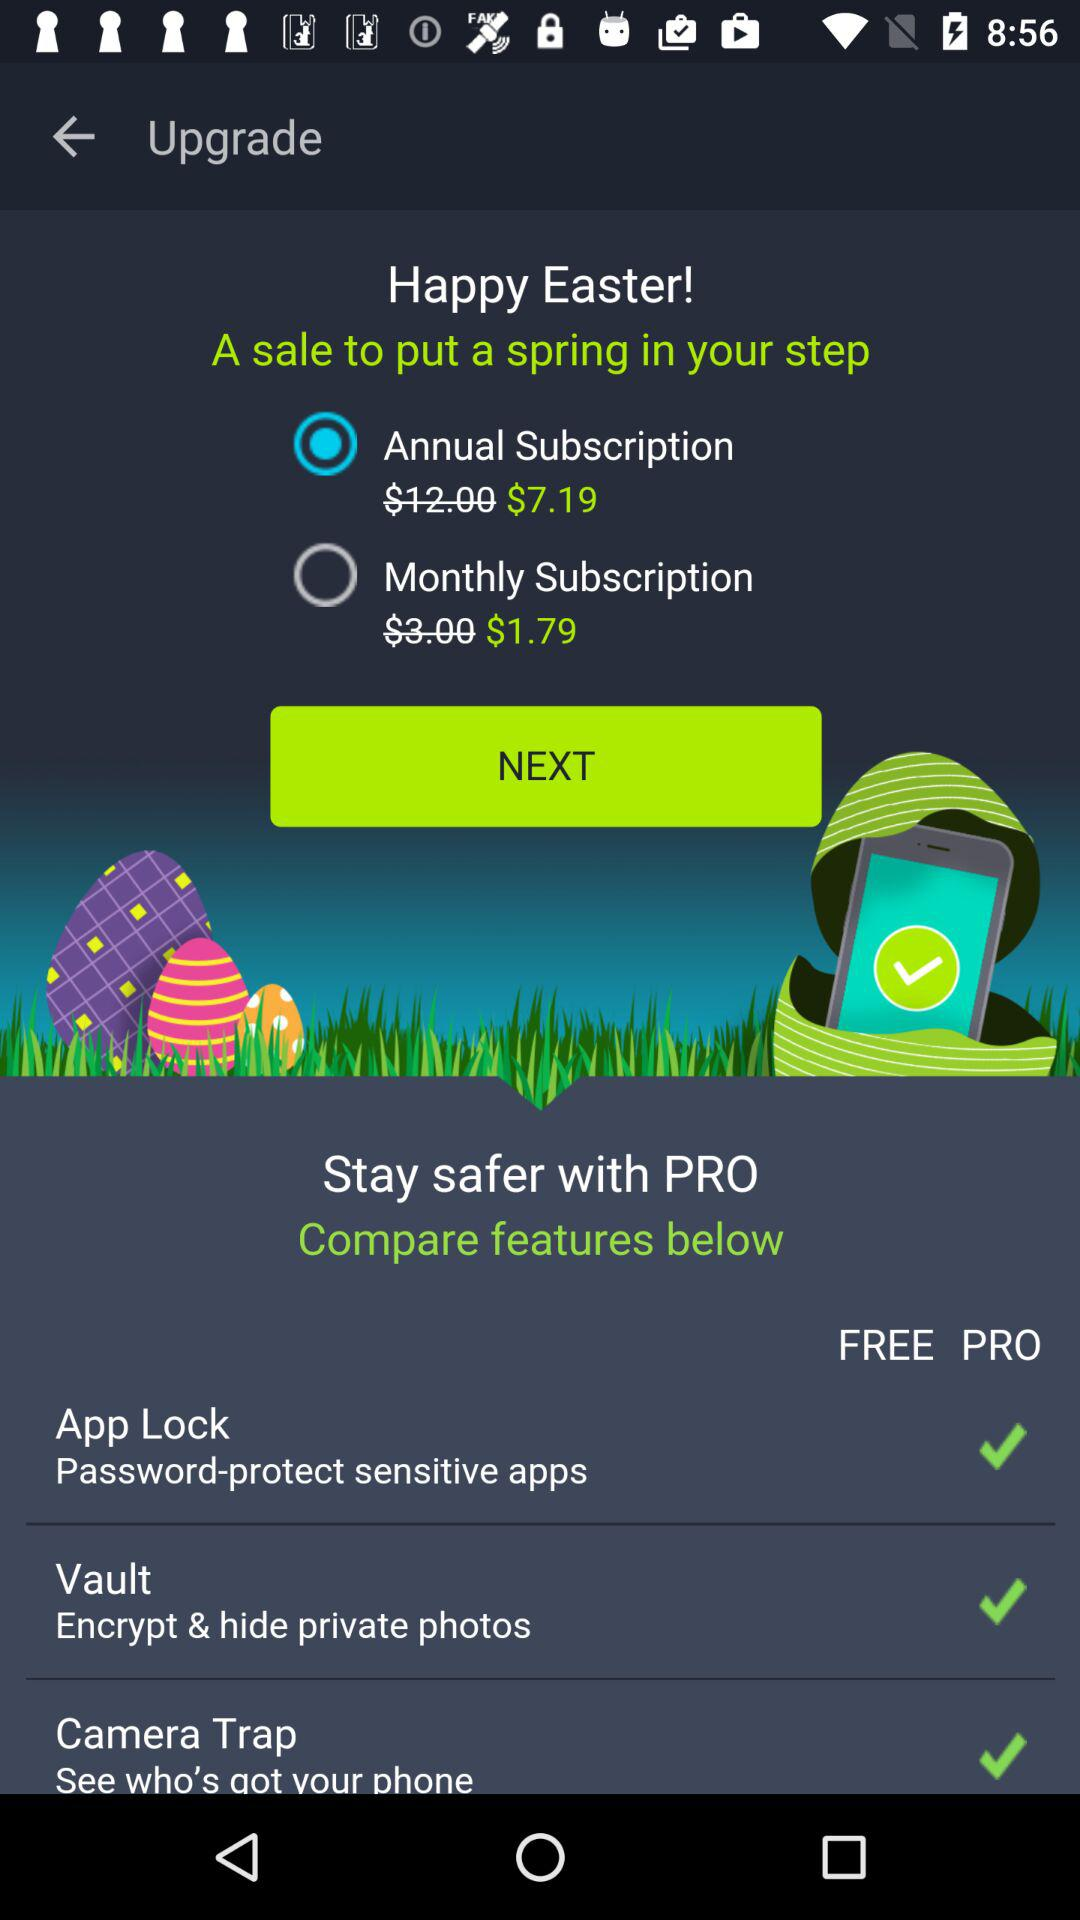Which app can be used to keep crucial apps safe?
When the provided information is insufficient, respond with <no answer>. <no answer> 